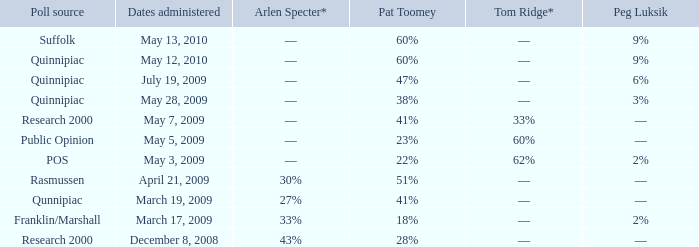Which Poll source has Pat Toomey of 23%? Public Opinion. 